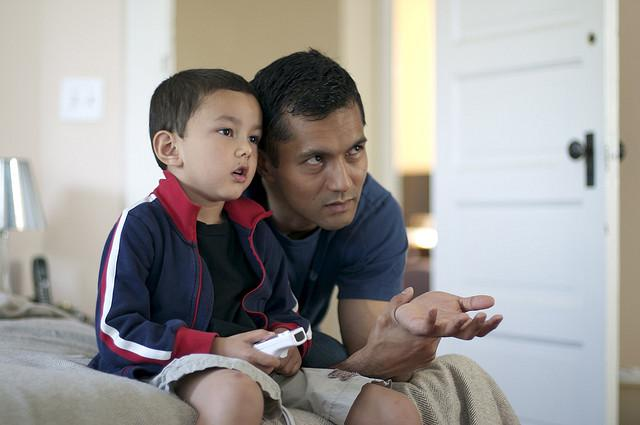What is the man helping the young boy do? play wii 